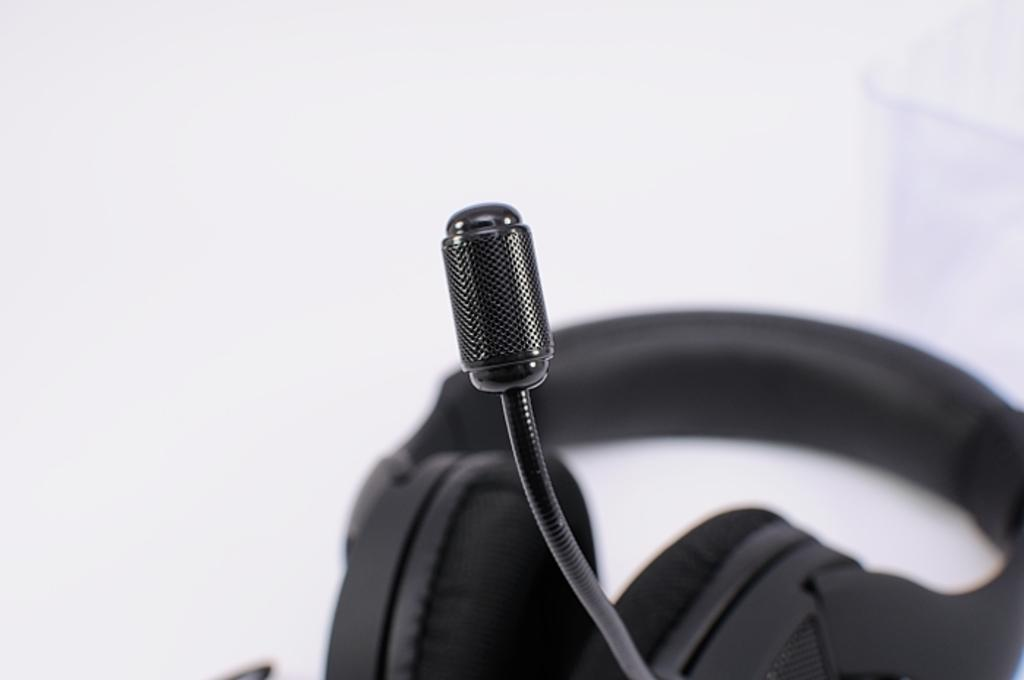What is the main object in the foreground of the image? There is a mic in the foreground of the image. What can be seen in the background of the image? There is a headset in the background of the image. What is the color of the surface on which the headset is placed? The headset is on a white surface. What type of authority figure is present in the image? There is no authority figure present in the image. How many boys are visible in the image? There are no boys visible in the image. 